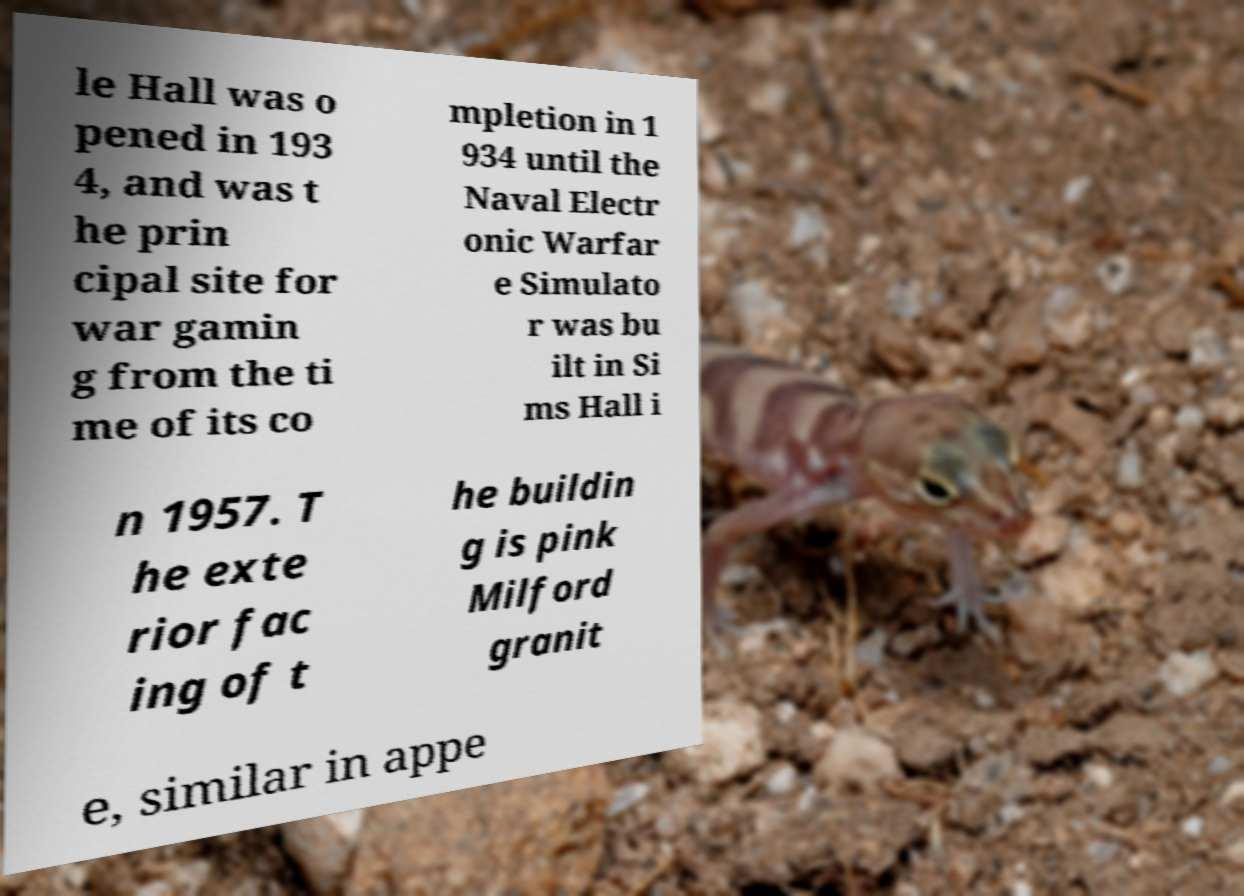Can you read and provide the text displayed in the image?This photo seems to have some interesting text. Can you extract and type it out for me? le Hall was o pened in 193 4, and was t he prin cipal site for war gamin g from the ti me of its co mpletion in 1 934 until the Naval Electr onic Warfar e Simulato r was bu ilt in Si ms Hall i n 1957. T he exte rior fac ing of t he buildin g is pink Milford granit e, similar in appe 